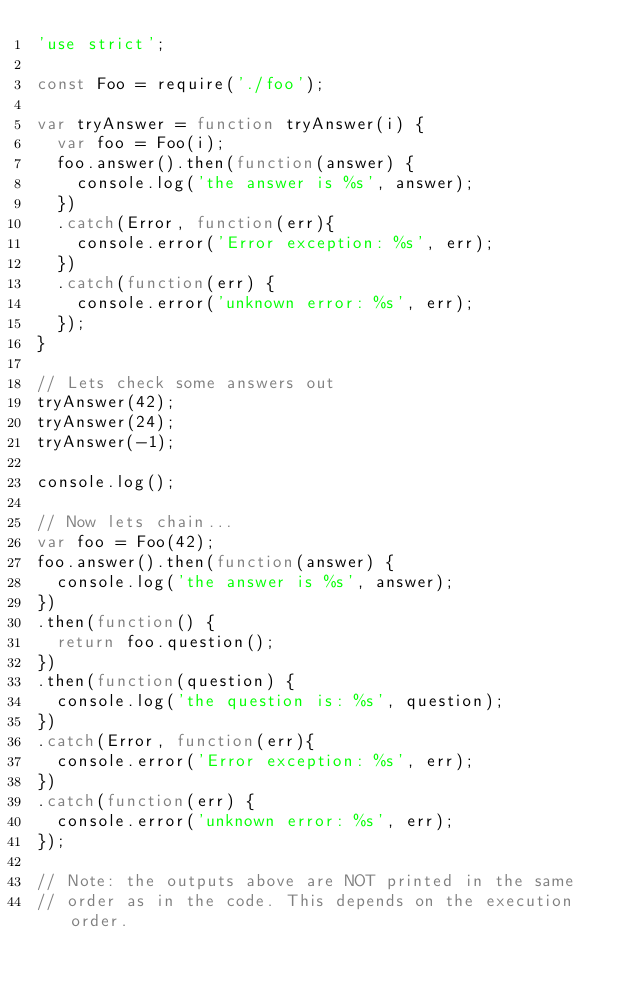<code> <loc_0><loc_0><loc_500><loc_500><_JavaScript_>'use strict';

const Foo = require('./foo');

var tryAnswer = function tryAnswer(i) {
  var foo = Foo(i);
  foo.answer().then(function(answer) {
    console.log('the answer is %s', answer);
  })
  .catch(Error, function(err){
    console.error('Error exception: %s', err);
  })
  .catch(function(err) {
    console.error('unknown error: %s', err);
  });
}

// Lets check some answers out
tryAnswer(42);
tryAnswer(24);
tryAnswer(-1);

console.log();

// Now lets chain...
var foo = Foo(42);
foo.answer().then(function(answer) {
  console.log('the answer is %s', answer);
})
.then(function() {
  return foo.question();
})
.then(function(question) {
  console.log('the question is: %s', question);
})
.catch(Error, function(err){
  console.error('Error exception: %s', err);
})
.catch(function(err) {
  console.error('unknown error: %s', err);
});

// Note: the outputs above are NOT printed in the same
// order as in the code. This depends on the execution order.
</code> 